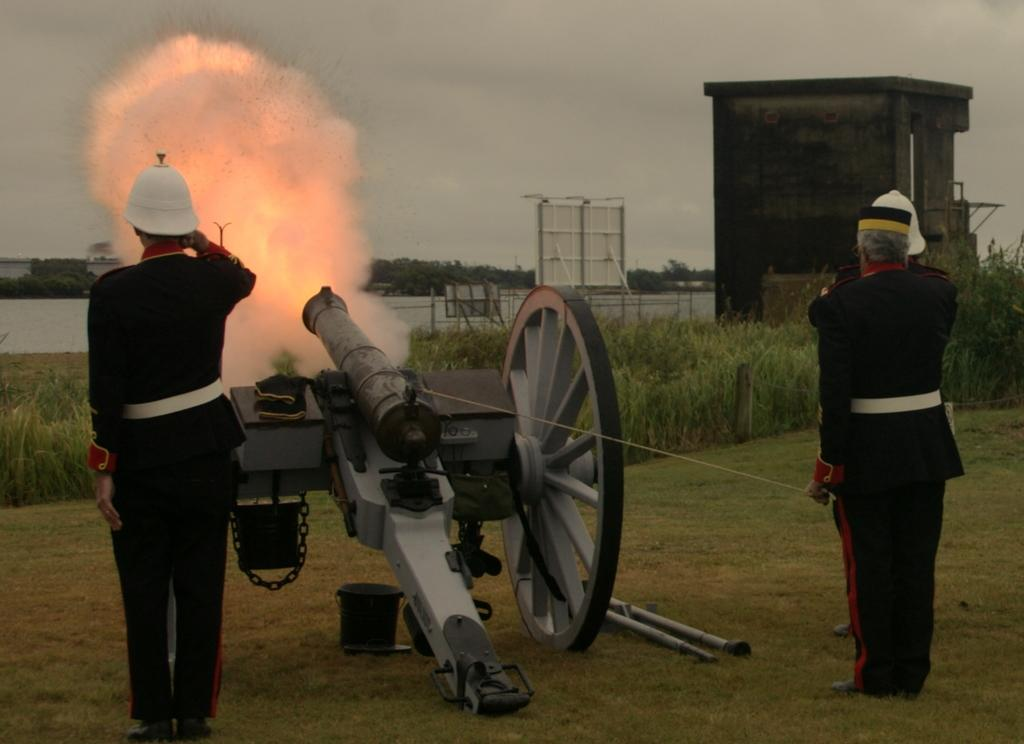Who or what can be seen in the image? There are people in the image. What object is on the ground in the image? There is a cannon on the ground. What can be seen in the background of the image? There is fire, trees, plants, a shed, and the sky visible in the background. Can you describe the unspecified objects in the background? Unfortunately, the facts provided do not specify the nature of the unspecified objects in the background. How much honey is being consumed by the people in the image? There is no mention of honey in the image, so it cannot be determined if any is being consumed. 